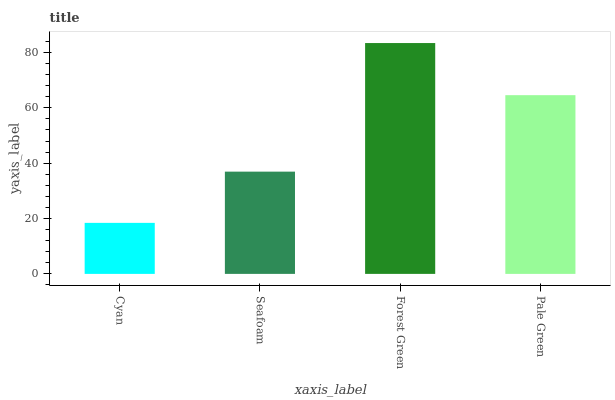Is Cyan the minimum?
Answer yes or no. Yes. Is Forest Green the maximum?
Answer yes or no. Yes. Is Seafoam the minimum?
Answer yes or no. No. Is Seafoam the maximum?
Answer yes or no. No. Is Seafoam greater than Cyan?
Answer yes or no. Yes. Is Cyan less than Seafoam?
Answer yes or no. Yes. Is Cyan greater than Seafoam?
Answer yes or no. No. Is Seafoam less than Cyan?
Answer yes or no. No. Is Pale Green the high median?
Answer yes or no. Yes. Is Seafoam the low median?
Answer yes or no. Yes. Is Cyan the high median?
Answer yes or no. No. Is Pale Green the low median?
Answer yes or no. No. 